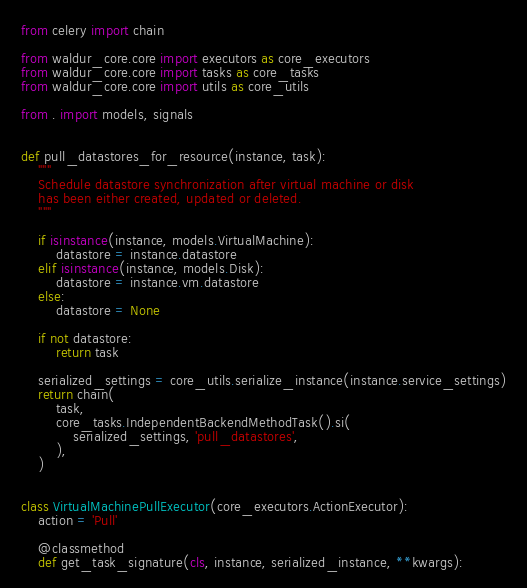Convert code to text. <code><loc_0><loc_0><loc_500><loc_500><_Python_>from celery import chain

from waldur_core.core import executors as core_executors
from waldur_core.core import tasks as core_tasks
from waldur_core.core import utils as core_utils

from . import models, signals


def pull_datastores_for_resource(instance, task):
    """
    Schedule datastore synchronization after virtual machine or disk
    has been either created, updated or deleted.
    """

    if isinstance(instance, models.VirtualMachine):
        datastore = instance.datastore
    elif isinstance(instance, models.Disk):
        datastore = instance.vm.datastore
    else:
        datastore = None

    if not datastore:
        return task

    serialized_settings = core_utils.serialize_instance(instance.service_settings)
    return chain(
        task,
        core_tasks.IndependentBackendMethodTask().si(
            serialized_settings, 'pull_datastores',
        ),
    )


class VirtualMachinePullExecutor(core_executors.ActionExecutor):
    action = 'Pull'

    @classmethod
    def get_task_signature(cls, instance, serialized_instance, **kwargs):</code> 